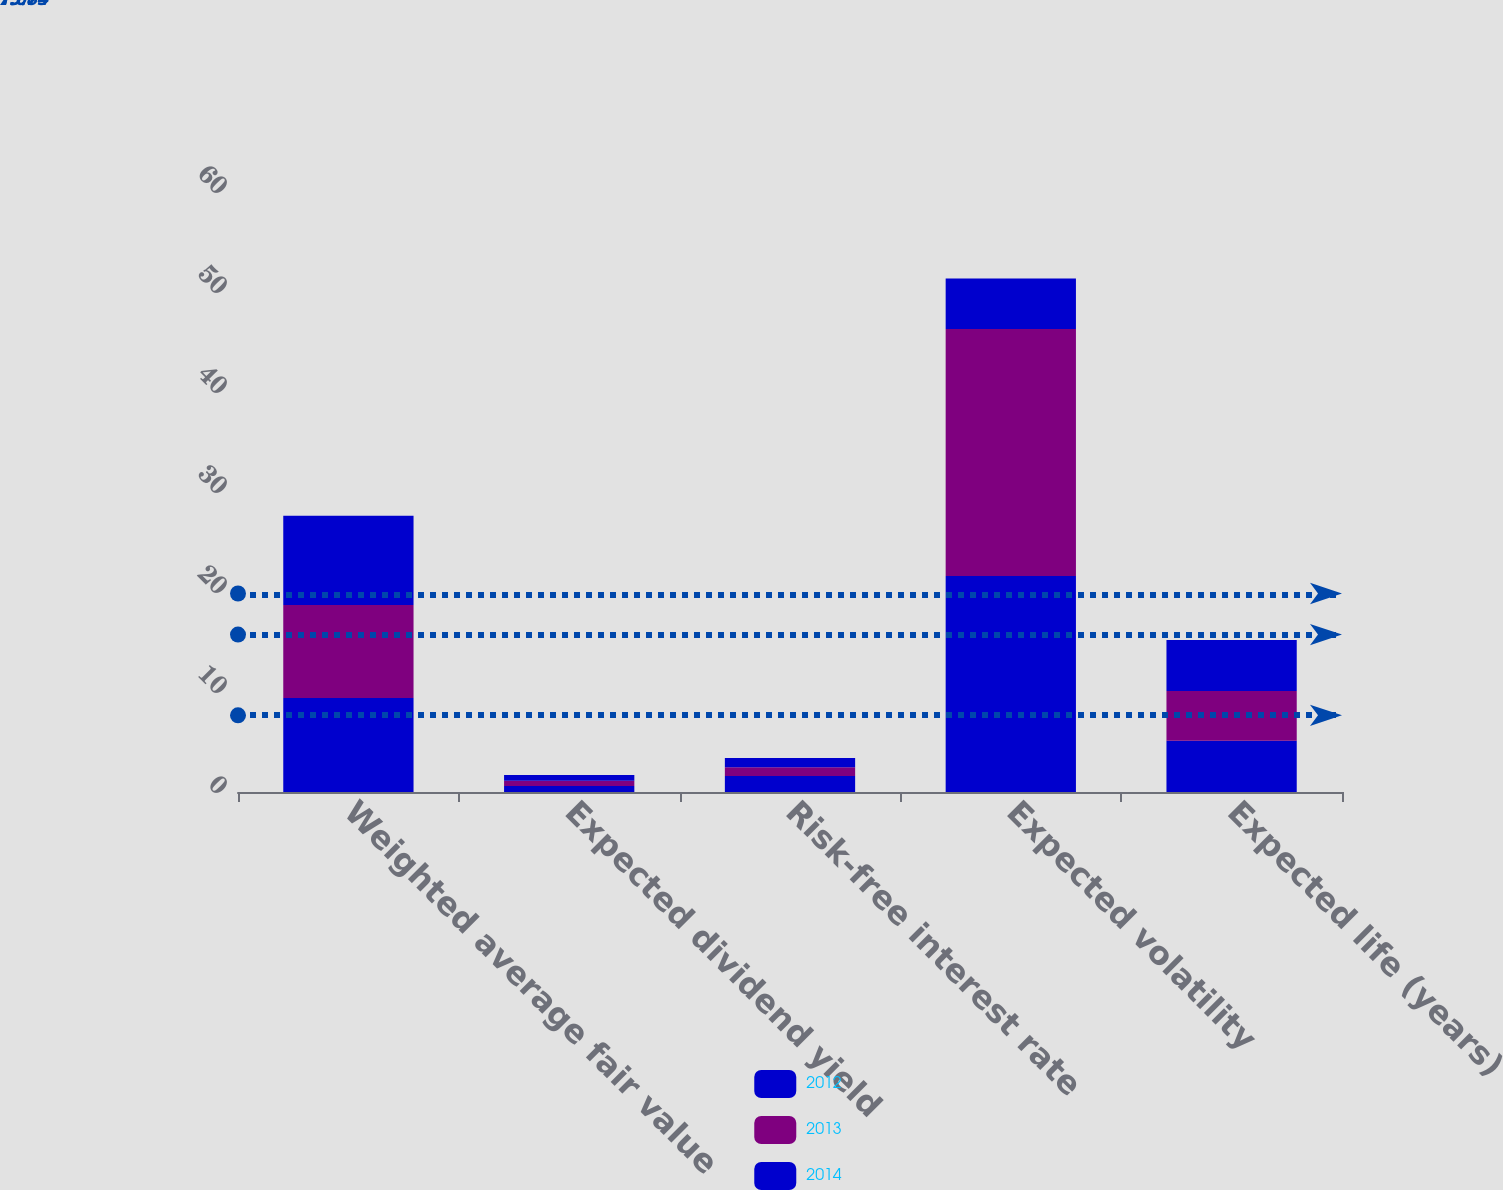Convert chart to OTSL. <chart><loc_0><loc_0><loc_500><loc_500><stacked_bar_chart><ecel><fcel>Weighted average fair value<fcel>Expected dividend yield<fcel>Risk-free interest rate<fcel>Expected volatility<fcel>Expected life (years)<nl><fcel>2012<fcel>9.41<fcel>0.59<fcel>1.61<fcel>21.6<fcel>5.13<nl><fcel>2013<fcel>9.3<fcel>0.53<fcel>0.87<fcel>24.7<fcel>4.98<nl><fcel>2014<fcel>8.91<fcel>0.57<fcel>0.93<fcel>5.04<fcel>5.1<nl></chart> 